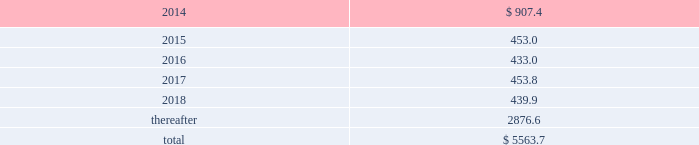Maturities of long-term debt in each of the next five years and beyond are as follows: .
On 4 february 2013 , we issued a $ 400.0 senior fixed-rate 2.75% ( 2.75 % ) note that matures on 3 february 2023 .
Additionally , on 7 august 2013 , we issued a 2.0% ( 2.0 % ) eurobond for 20ac300 million ( $ 397 ) that matures on 7 august 2020 .
Various debt agreements to which we are a party also include financial covenants and other restrictions , including restrictions pertaining to the ability to create property liens and enter into certain sale and leaseback transactions .
As of 30 september 2013 , we are in compliance with all the financial and other covenants under our debt agreements .
As of 30 september 2013 , we have classified commercial paper of $ 400.0 maturing in 2014 as long-term debt because we have the ability and intent to refinance the debt under our $ 2500.0 committed credit facility maturing in 2018 .
Our current intent is to refinance this debt via the u.s .
Public or private placement markets .
On 30 april 2013 , we entered into a five-year $ 2500.0 revolving credit agreement with a syndicate of banks ( the 201c2013 credit agreement 201d ) , under which senior unsecured debt is available to us and certain of our subsidiaries .
The 2013 credit agreement provides us with a source of liquidity and supports our commercial paper program .
This agreement increases the previously existing facility by $ 330.0 , extends the maturity date to 30 april 2018 , and modifies the financial covenant to a maximum ratio of total debt to total capitalization ( total debt plus total equity plus redeemable noncontrolling interest ) no greater than 70% ( 70 % ) .
No borrowings were outstanding under the 2013 credit agreement as of 30 september 2013 .
The 2013 credit agreement terminates and replaces our previous $ 2170.0 revolving credit agreement dated 8 july 2010 , as subsequently amended , which was to mature 30 june 2015 and had a financial covenant of long-term debt divided by the sum of long-term debt plus equity of no greater than 60% ( 60 % ) .
No borrowings were outstanding under the previous agreement at the time of its termination and no early termination penalties were incurred .
Effective 11 june 2012 , we entered into an offshore chinese renminbi ( rmb ) syndicated credit facility of rmb1000.0 million ( $ 163.5 ) , maturing in june 2015 .
There are rmb250.0 million ( $ 40.9 ) in outstanding borrowings under this commitment at 30 september 2013 .
Additional commitments totaling $ 383.0 are maintained by our foreign subsidiaries , of which $ 309.0 was borrowed and outstanding at 30 september 2013. .
What is going to be the matured value of the eurobond issued in 2013 , in millions? 
Rationale: it is the original $ 397 calculated in the compound interest formula , in which 2% is going to be the interest and 7 is going to be the period ( 2020-2013 ) .
Computations: (397 * ((1 + 2.0%) ** 7))
Answer: 456.02821. 